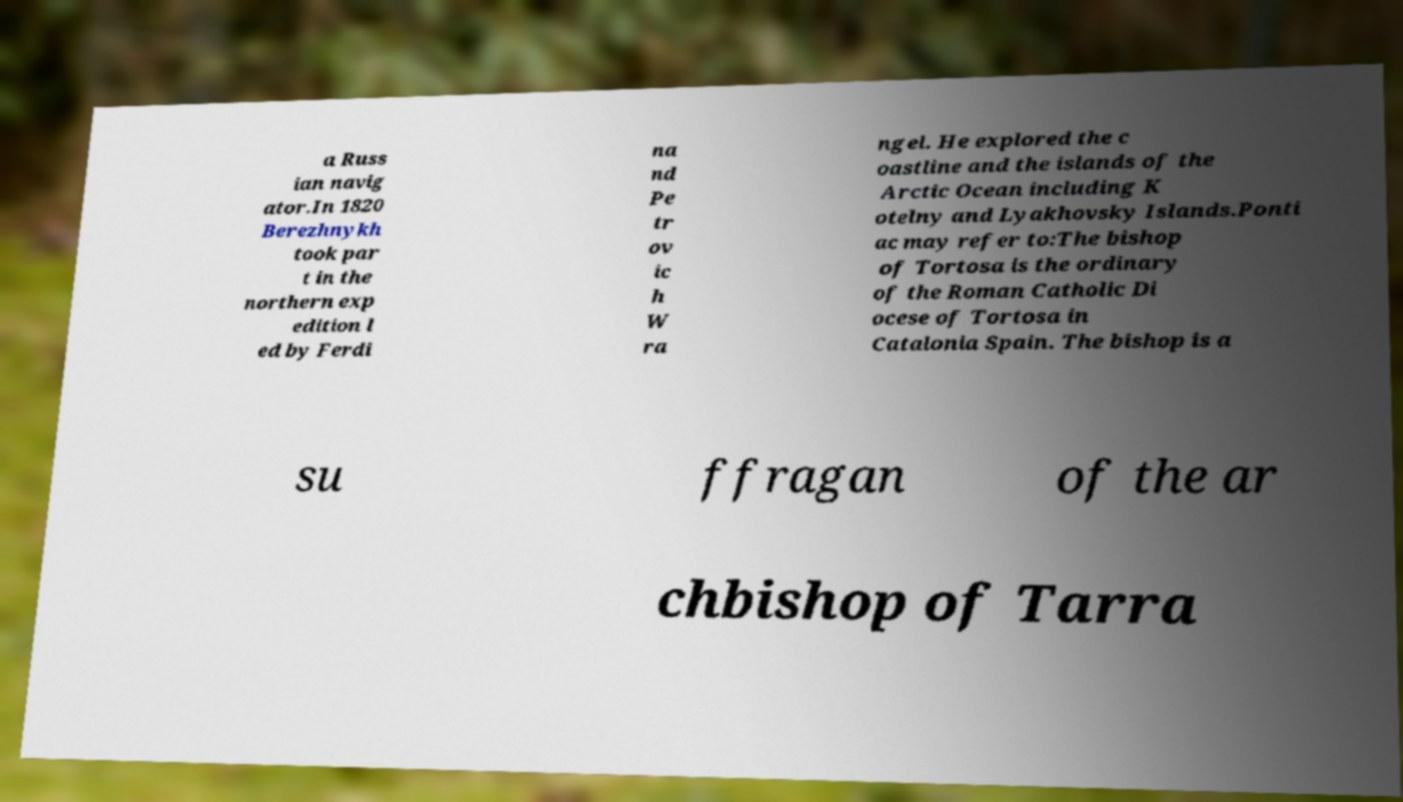For documentation purposes, I need the text within this image transcribed. Could you provide that? a Russ ian navig ator.In 1820 Berezhnykh took par t in the northern exp edition l ed by Ferdi na nd Pe tr ov ic h W ra ngel. He explored the c oastline and the islands of the Arctic Ocean including K otelny and Lyakhovsky Islands.Ponti ac may refer to:The bishop of Tortosa is the ordinary of the Roman Catholic Di ocese of Tortosa in Catalonia Spain. The bishop is a su ffragan of the ar chbishop of Tarra 